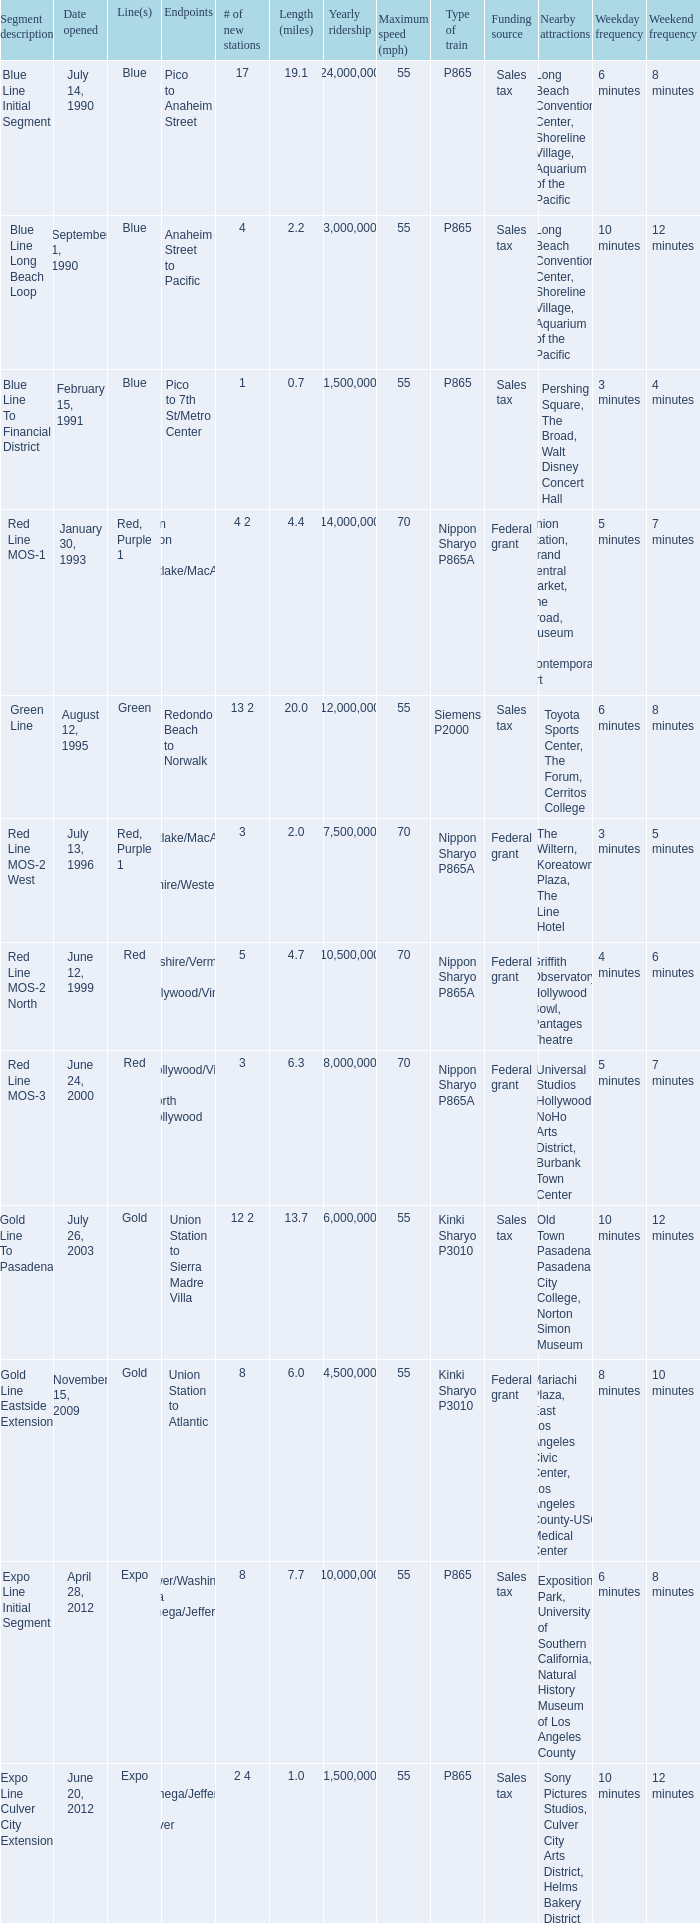What date of segment description red line mos-2 north open? June 12, 1999. 